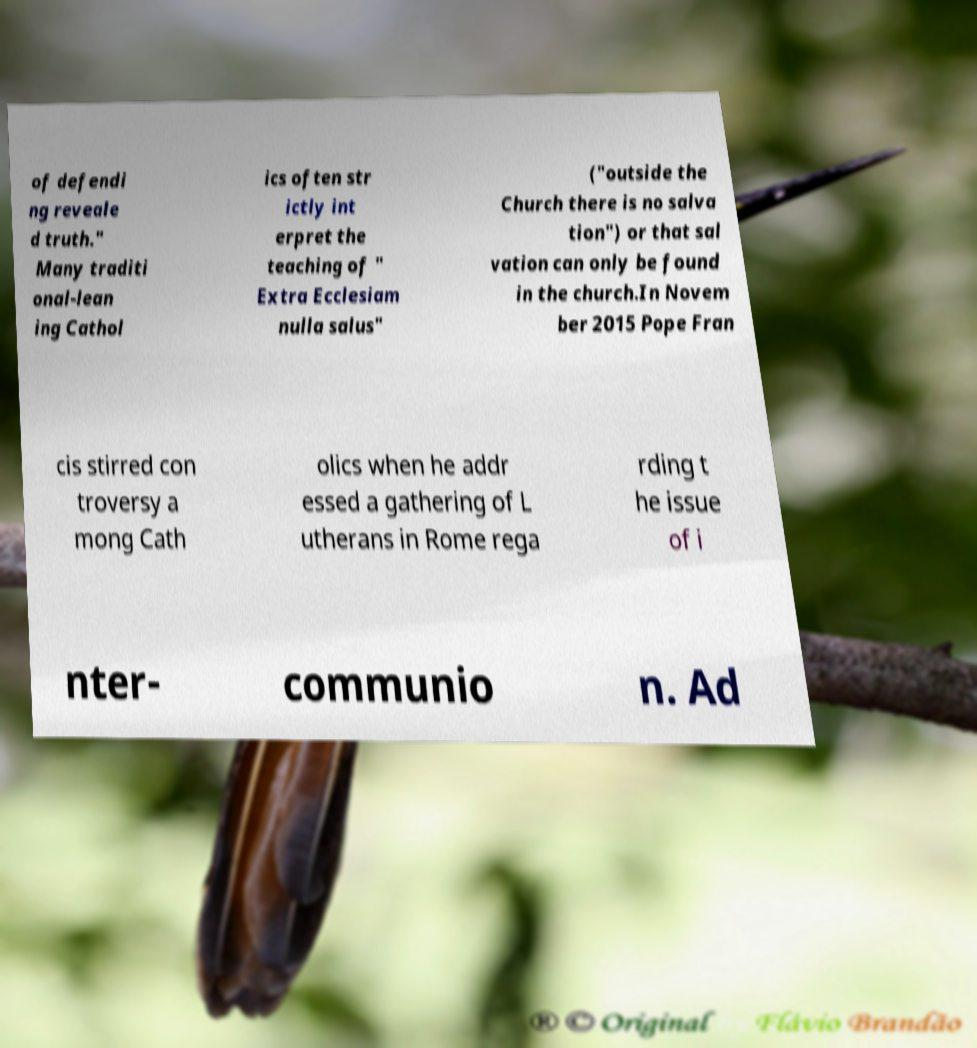What messages or text are displayed in this image? I need them in a readable, typed format. of defendi ng reveale d truth." Many traditi onal-lean ing Cathol ics often str ictly int erpret the teaching of " Extra Ecclesiam nulla salus" ("outside the Church there is no salva tion") or that sal vation can only be found in the church.In Novem ber 2015 Pope Fran cis stirred con troversy a mong Cath olics when he addr essed a gathering of L utherans in Rome rega rding t he issue of i nter- communio n. Ad 